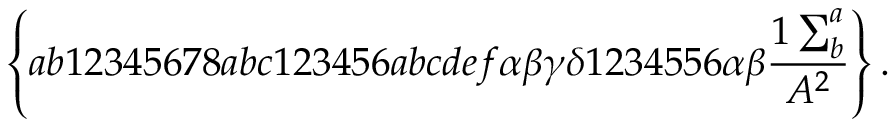<formula> <loc_0><loc_0><loc_500><loc_500>\left \{ a b 1 2 3 4 5 6 7 8 a b c 1 2 3 4 5 6 a b c d e f \alpha \beta \gamma \delta 1 2 3 4 5 5 6 \alpha \beta \frac { 1 \sum _ { b } ^ { a } } { A ^ { 2 } } \right \} .</formula> 